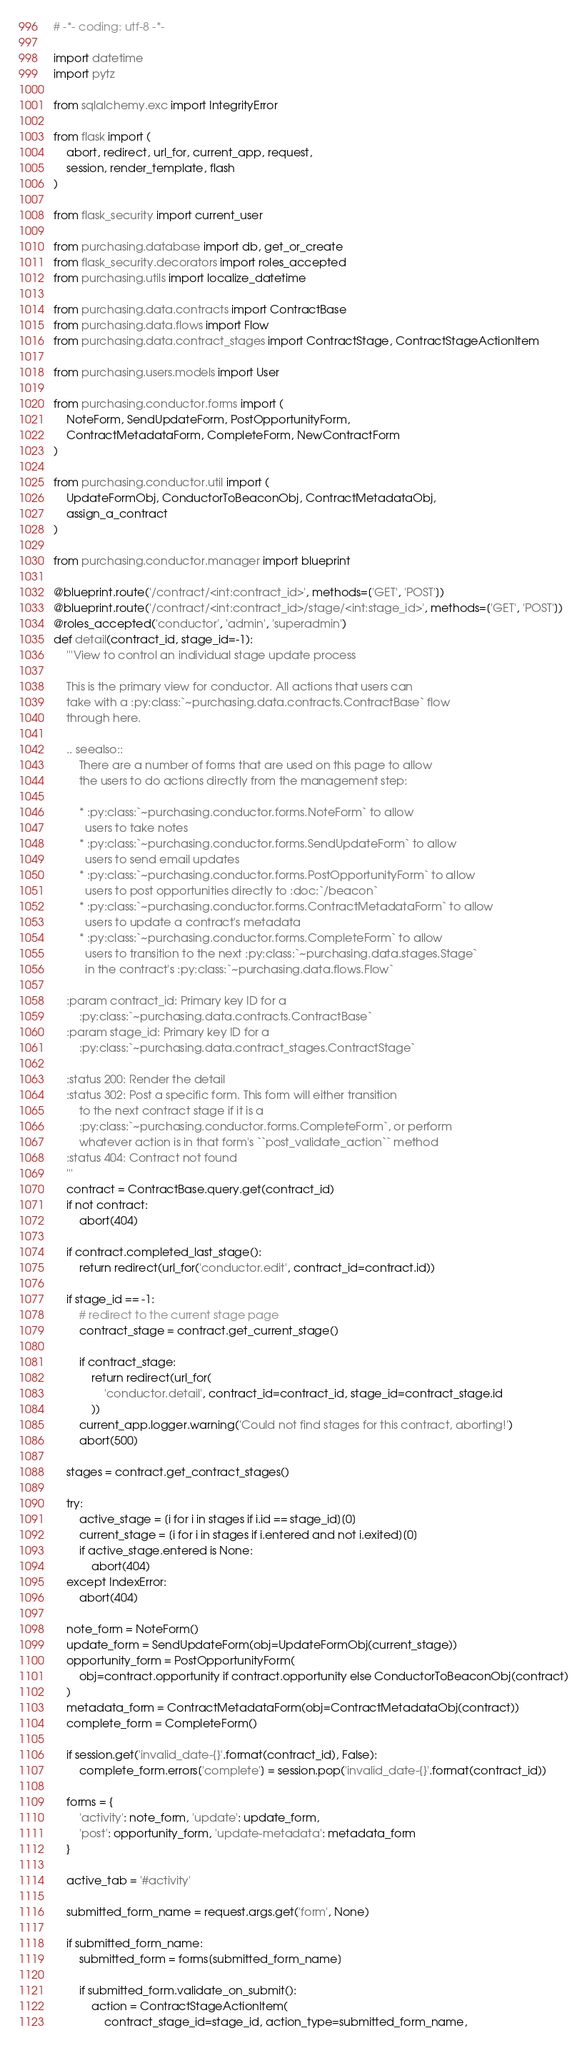<code> <loc_0><loc_0><loc_500><loc_500><_Python_># -*- coding: utf-8 -*-

import datetime
import pytz

from sqlalchemy.exc import IntegrityError

from flask import (
    abort, redirect, url_for, current_app, request,
    session, render_template, flash
)

from flask_security import current_user

from purchasing.database import db, get_or_create
from flask_security.decorators import roles_accepted
from purchasing.utils import localize_datetime

from purchasing.data.contracts import ContractBase
from purchasing.data.flows import Flow
from purchasing.data.contract_stages import ContractStage, ContractStageActionItem

from purchasing.users.models import User

from purchasing.conductor.forms import (
    NoteForm, SendUpdateForm, PostOpportunityForm,
    ContractMetadataForm, CompleteForm, NewContractForm
)

from purchasing.conductor.util import (
    UpdateFormObj, ConductorToBeaconObj, ContractMetadataObj,
    assign_a_contract
)

from purchasing.conductor.manager import blueprint

@blueprint.route('/contract/<int:contract_id>', methods=['GET', 'POST'])
@blueprint.route('/contract/<int:contract_id>/stage/<int:stage_id>', methods=['GET', 'POST'])
@roles_accepted('conductor', 'admin', 'superadmin')
def detail(contract_id, stage_id=-1):
    '''View to control an individual stage update process

    This is the primary view for conductor. All actions that users can
    take with a :py:class:`~purchasing.data.contracts.ContractBase` flow
    through here.

    .. seealso::
        There are a number of forms that are used on this page to allow
        the users to do actions directly from the management step:

        * :py:class:`~purchasing.conductor.forms.NoteForm` to allow
          users to take notes
        * :py:class:`~purchasing.conductor.forms.SendUpdateForm` to allow
          users to send email updates
        * :py:class:`~purchasing.conductor.forms.PostOpportunityForm` to allow
          users to post opportunities directly to :doc:`/beacon`
        * :py:class:`~purchasing.conductor.forms.ContractMetadataForm` to allow
          users to update a contract's metadata
        * :py:class:`~purchasing.conductor.forms.CompleteForm` to allow
          users to transition to the next :py:class:`~purchasing.data.stages.Stage`
          in the contract's :py:class:`~purchasing.data.flows.Flow`

    :param contract_id: Primary key ID for a
        :py:class:`~purchasing.data.contracts.ContractBase`
    :param stage_id: Primary key ID for a
        :py:class:`~purchasing.data.contract_stages.ContractStage`

    :status 200: Render the detail
    :status 302: Post a specific form. This form will either transition
        to the next contract stage if it is a
        :py:class:`~purchasing.conductor.forms.CompleteForm`, or perform
        whatever action is in that form's ``post_validate_action`` method
    :status 404: Contract not found
    '''
    contract = ContractBase.query.get(contract_id)
    if not contract:
        abort(404)

    if contract.completed_last_stage():
        return redirect(url_for('conductor.edit', contract_id=contract.id))

    if stage_id == -1:
        # redirect to the current stage page
        contract_stage = contract.get_current_stage()

        if contract_stage:
            return redirect(url_for(
                'conductor.detail', contract_id=contract_id, stage_id=contract_stage.id
            ))
        current_app.logger.warning('Could not find stages for this contract, aborting!')
        abort(500)

    stages = contract.get_contract_stages()

    try:
        active_stage = [i for i in stages if i.id == stage_id][0]
        current_stage = [i for i in stages if i.entered and not i.exited][0]
        if active_stage.entered is None:
            abort(404)
    except IndexError:
        abort(404)

    note_form = NoteForm()
    update_form = SendUpdateForm(obj=UpdateFormObj(current_stage))
    opportunity_form = PostOpportunityForm(
        obj=contract.opportunity if contract.opportunity else ConductorToBeaconObj(contract)
    )
    metadata_form = ContractMetadataForm(obj=ContractMetadataObj(contract))
    complete_form = CompleteForm()

    if session.get('invalid_date-{}'.format(contract_id), False):
        complete_form.errors['complete'] = session.pop('invalid_date-{}'.format(contract_id))

    forms = {
        'activity': note_form, 'update': update_form,
        'post': opportunity_form, 'update-metadata': metadata_form
    }

    active_tab = '#activity'

    submitted_form_name = request.args.get('form', None)

    if submitted_form_name:
        submitted_form = forms[submitted_form_name]

        if submitted_form.validate_on_submit():
            action = ContractStageActionItem(
                contract_stage_id=stage_id, action_type=submitted_form_name,</code> 